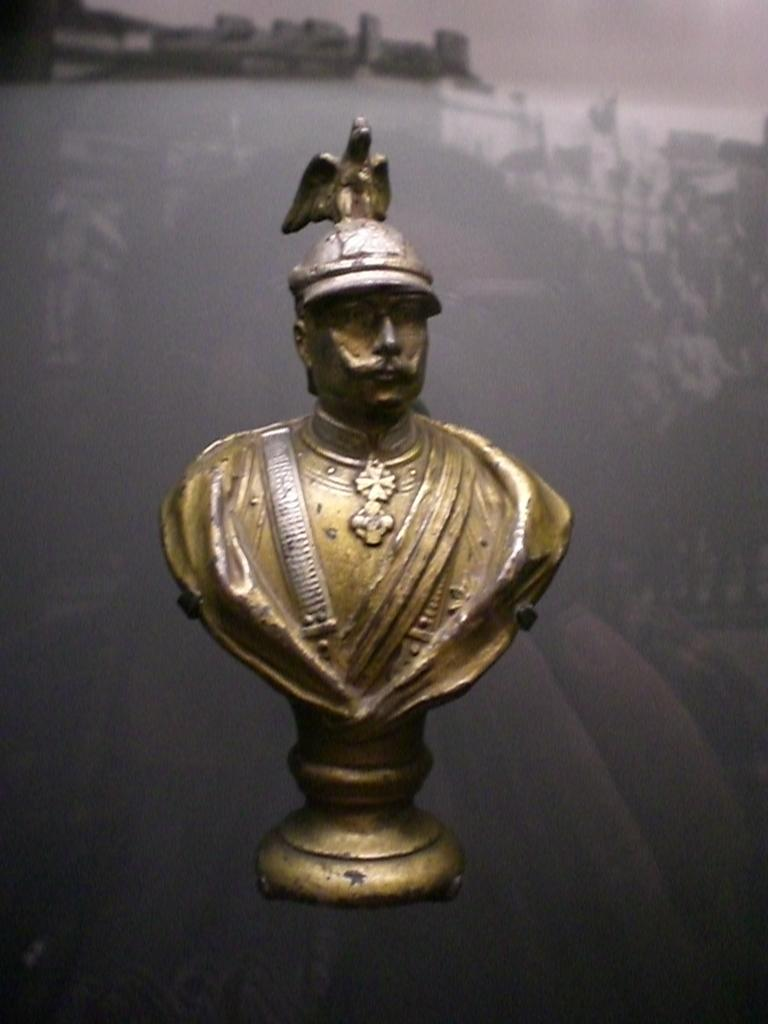What type of sculpture is in the image? There is a bronze sculpture in the image. What can be seen in the background of the image? There is a reflection of buildings on the glass in the background of the image. Where is the bottle placed in the image? There is no bottle present in the image. What type of oven is used to create the bronze sculpture in the image? The image does not show the process of creating the bronze sculpture, so it is not possible to determine what type of oven was used. 